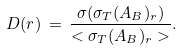Convert formula to latex. <formula><loc_0><loc_0><loc_500><loc_500>D ( r ) \, = \, \frac { \sigma ( \sigma _ { T } ( A _ { B } ) _ { r } ) } { < \sigma _ { T } ( A _ { B } ) _ { r } > } .</formula> 